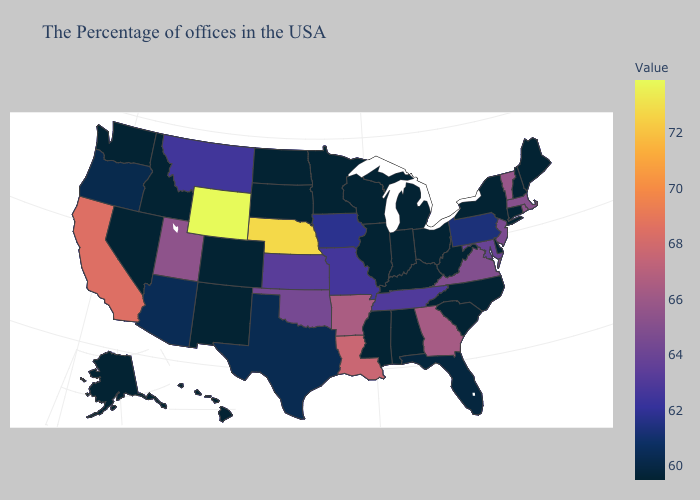Which states have the highest value in the USA?
Be succinct. Wyoming. Among the states that border Michigan , which have the highest value?
Quick response, please. Ohio, Indiana, Wisconsin. Does Montana have a lower value than Oregon?
Write a very short answer. No. Does Kentucky have the highest value in the USA?
Quick response, please. No. Does Nebraska have the highest value in the MidWest?
Give a very brief answer. Yes. Which states hav the highest value in the West?
Answer briefly. Wyoming. Does Kansas have a higher value than Utah?
Write a very short answer. No. 